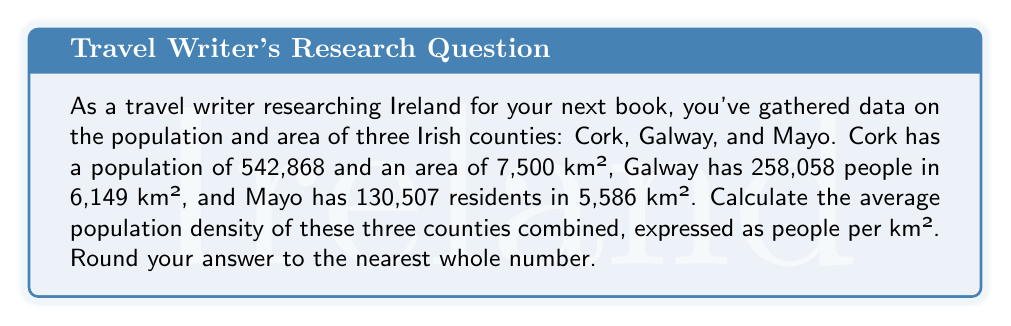Could you help me with this problem? To solve this problem, we'll follow these steps:

1. Calculate the total population of the three counties:
   $$P_{total} = 542,868 + 258,058 + 130,507 = 931,433$$

2. Calculate the total area of the three counties:
   $$A_{total} = 7,500 + 6,149 + 5,586 = 19,235 \text{ km}^2$$

3. Calculate the average population density using the formula:
   $$\text{Average Density} = \frac{\text{Total Population}}{\text{Total Area}}$$

4. Substitute the values:
   $$\text{Average Density} = \frac{931,433}{19,235} \approx 48.42 \text{ people/km}^2$$

5. Round to the nearest whole number:
   $$48.42 \approx 48 \text{ people/km}^2$$

This calculation provides an overall picture of the population distribution across these three Irish counties, which can be useful for comparing different regions in your travel book.
Answer: 48 people/km² 